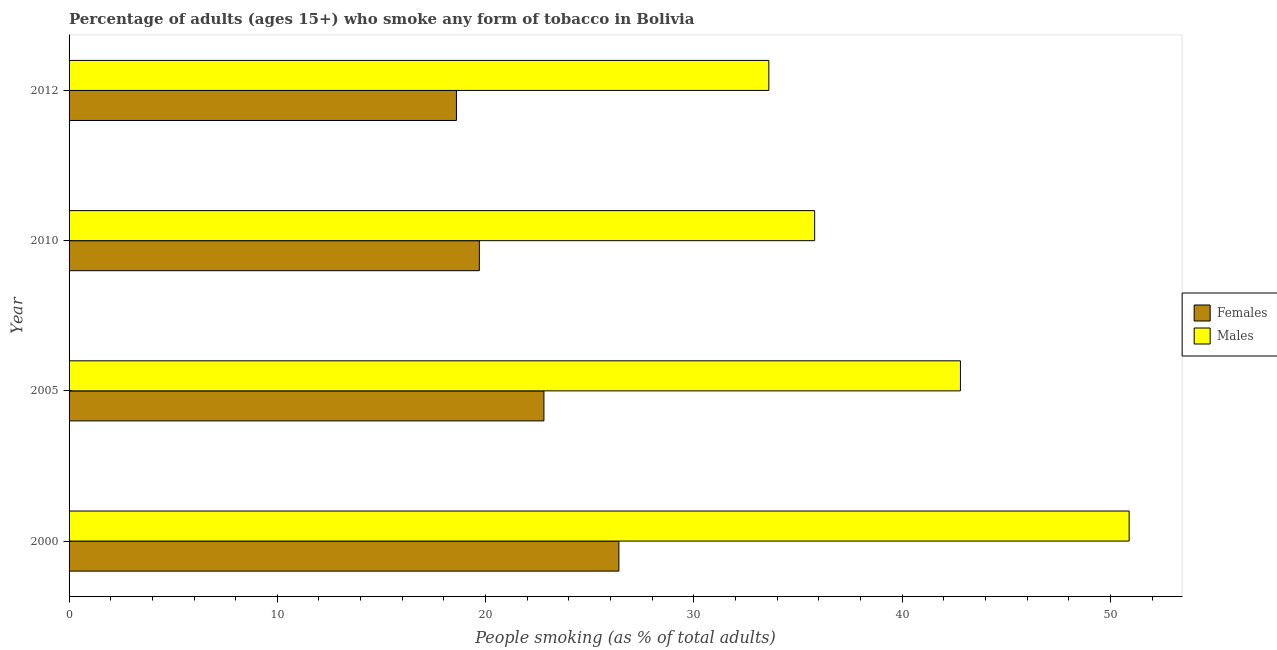How many groups of bars are there?
Make the answer very short. 4. Are the number of bars per tick equal to the number of legend labels?
Your answer should be compact. Yes. Are the number of bars on each tick of the Y-axis equal?
Make the answer very short. Yes. In how many cases, is the number of bars for a given year not equal to the number of legend labels?
Your answer should be very brief. 0. What is the percentage of females who smoke in 2010?
Provide a succinct answer. 19.7. Across all years, what is the maximum percentage of females who smoke?
Your answer should be very brief. 26.4. Across all years, what is the minimum percentage of males who smoke?
Your answer should be compact. 33.6. In which year was the percentage of females who smoke maximum?
Make the answer very short. 2000. In which year was the percentage of males who smoke minimum?
Your answer should be very brief. 2012. What is the total percentage of females who smoke in the graph?
Your answer should be very brief. 87.5. What is the difference between the percentage of males who smoke in 2005 and that in 2012?
Ensure brevity in your answer.  9.2. What is the difference between the percentage of males who smoke in 2000 and the percentage of females who smoke in 2005?
Offer a very short reply. 28.1. What is the average percentage of females who smoke per year?
Provide a short and direct response. 21.88. In the year 2005, what is the difference between the percentage of males who smoke and percentage of females who smoke?
Provide a succinct answer. 20. What is the ratio of the percentage of males who smoke in 2000 to that in 2012?
Keep it short and to the point. 1.51. Is the difference between the percentage of females who smoke in 2000 and 2010 greater than the difference between the percentage of males who smoke in 2000 and 2010?
Your response must be concise. No. What is the difference between the highest and the lowest percentage of males who smoke?
Offer a very short reply. 17.3. In how many years, is the percentage of males who smoke greater than the average percentage of males who smoke taken over all years?
Offer a terse response. 2. What does the 2nd bar from the top in 2012 represents?
Your response must be concise. Females. What does the 2nd bar from the bottom in 2005 represents?
Give a very brief answer. Males. Are the values on the major ticks of X-axis written in scientific E-notation?
Your answer should be very brief. No. Does the graph contain grids?
Your answer should be compact. No. Where does the legend appear in the graph?
Give a very brief answer. Center right. How many legend labels are there?
Your response must be concise. 2. How are the legend labels stacked?
Keep it short and to the point. Vertical. What is the title of the graph?
Your response must be concise. Percentage of adults (ages 15+) who smoke any form of tobacco in Bolivia. Does "Non-resident workers" appear as one of the legend labels in the graph?
Keep it short and to the point. No. What is the label or title of the X-axis?
Give a very brief answer. People smoking (as % of total adults). What is the label or title of the Y-axis?
Make the answer very short. Year. What is the People smoking (as % of total adults) of Females in 2000?
Make the answer very short. 26.4. What is the People smoking (as % of total adults) of Males in 2000?
Your response must be concise. 50.9. What is the People smoking (as % of total adults) of Females in 2005?
Keep it short and to the point. 22.8. What is the People smoking (as % of total adults) in Males in 2005?
Your answer should be very brief. 42.8. What is the People smoking (as % of total adults) in Females in 2010?
Provide a short and direct response. 19.7. What is the People smoking (as % of total adults) in Males in 2010?
Give a very brief answer. 35.8. What is the People smoking (as % of total adults) of Males in 2012?
Your response must be concise. 33.6. Across all years, what is the maximum People smoking (as % of total adults) of Females?
Make the answer very short. 26.4. Across all years, what is the maximum People smoking (as % of total adults) in Males?
Ensure brevity in your answer.  50.9. Across all years, what is the minimum People smoking (as % of total adults) in Males?
Your response must be concise. 33.6. What is the total People smoking (as % of total adults) of Females in the graph?
Make the answer very short. 87.5. What is the total People smoking (as % of total adults) in Males in the graph?
Offer a terse response. 163.1. What is the difference between the People smoking (as % of total adults) in Females in 2000 and that in 2005?
Your answer should be very brief. 3.6. What is the difference between the People smoking (as % of total adults) of Males in 2000 and that in 2005?
Provide a succinct answer. 8.1. What is the difference between the People smoking (as % of total adults) in Females in 2000 and that in 2010?
Keep it short and to the point. 6.7. What is the difference between the People smoking (as % of total adults) of Males in 2000 and that in 2010?
Your answer should be compact. 15.1. What is the difference between the People smoking (as % of total adults) in Females in 2000 and that in 2012?
Ensure brevity in your answer.  7.8. What is the difference between the People smoking (as % of total adults) of Males in 2000 and that in 2012?
Your response must be concise. 17.3. What is the difference between the People smoking (as % of total adults) of Females in 2005 and that in 2010?
Offer a terse response. 3.1. What is the difference between the People smoking (as % of total adults) in Females in 2000 and the People smoking (as % of total adults) in Males in 2005?
Your answer should be compact. -16.4. What is the difference between the People smoking (as % of total adults) of Females in 2000 and the People smoking (as % of total adults) of Males in 2010?
Your answer should be very brief. -9.4. What is the difference between the People smoking (as % of total adults) of Females in 2000 and the People smoking (as % of total adults) of Males in 2012?
Provide a short and direct response. -7.2. What is the difference between the People smoking (as % of total adults) in Females in 2005 and the People smoking (as % of total adults) in Males in 2012?
Your answer should be very brief. -10.8. What is the average People smoking (as % of total adults) of Females per year?
Give a very brief answer. 21.88. What is the average People smoking (as % of total adults) in Males per year?
Ensure brevity in your answer.  40.77. In the year 2000, what is the difference between the People smoking (as % of total adults) of Females and People smoking (as % of total adults) of Males?
Provide a short and direct response. -24.5. In the year 2010, what is the difference between the People smoking (as % of total adults) in Females and People smoking (as % of total adults) in Males?
Your answer should be very brief. -16.1. In the year 2012, what is the difference between the People smoking (as % of total adults) of Females and People smoking (as % of total adults) of Males?
Keep it short and to the point. -15. What is the ratio of the People smoking (as % of total adults) in Females in 2000 to that in 2005?
Your answer should be compact. 1.16. What is the ratio of the People smoking (as % of total adults) in Males in 2000 to that in 2005?
Your answer should be very brief. 1.19. What is the ratio of the People smoking (as % of total adults) of Females in 2000 to that in 2010?
Offer a terse response. 1.34. What is the ratio of the People smoking (as % of total adults) of Males in 2000 to that in 2010?
Provide a succinct answer. 1.42. What is the ratio of the People smoking (as % of total adults) in Females in 2000 to that in 2012?
Your answer should be very brief. 1.42. What is the ratio of the People smoking (as % of total adults) in Males in 2000 to that in 2012?
Provide a succinct answer. 1.51. What is the ratio of the People smoking (as % of total adults) of Females in 2005 to that in 2010?
Provide a short and direct response. 1.16. What is the ratio of the People smoking (as % of total adults) in Males in 2005 to that in 2010?
Provide a succinct answer. 1.2. What is the ratio of the People smoking (as % of total adults) in Females in 2005 to that in 2012?
Your response must be concise. 1.23. What is the ratio of the People smoking (as % of total adults) in Males in 2005 to that in 2012?
Your response must be concise. 1.27. What is the ratio of the People smoking (as % of total adults) of Females in 2010 to that in 2012?
Give a very brief answer. 1.06. What is the ratio of the People smoking (as % of total adults) in Males in 2010 to that in 2012?
Keep it short and to the point. 1.07. What is the difference between the highest and the lowest People smoking (as % of total adults) in Females?
Your answer should be compact. 7.8. What is the difference between the highest and the lowest People smoking (as % of total adults) in Males?
Your answer should be compact. 17.3. 